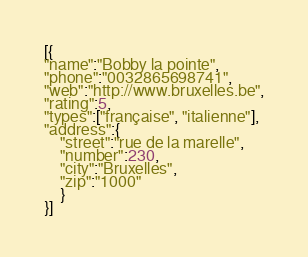<code> <loc_0><loc_0><loc_500><loc_500><_JavaScript_>[{
"name":"Bobby la pointe",
"phone":"0032865698741",
"web":"http://www.bruxelles.be",
"rating":5,
"types":["française", "italienne"],
"address":{
    "street":"rue de la marelle",
    "number":230,
    "city":"Bruxelles",
    "zip":"1000"
    }
}]</code> 